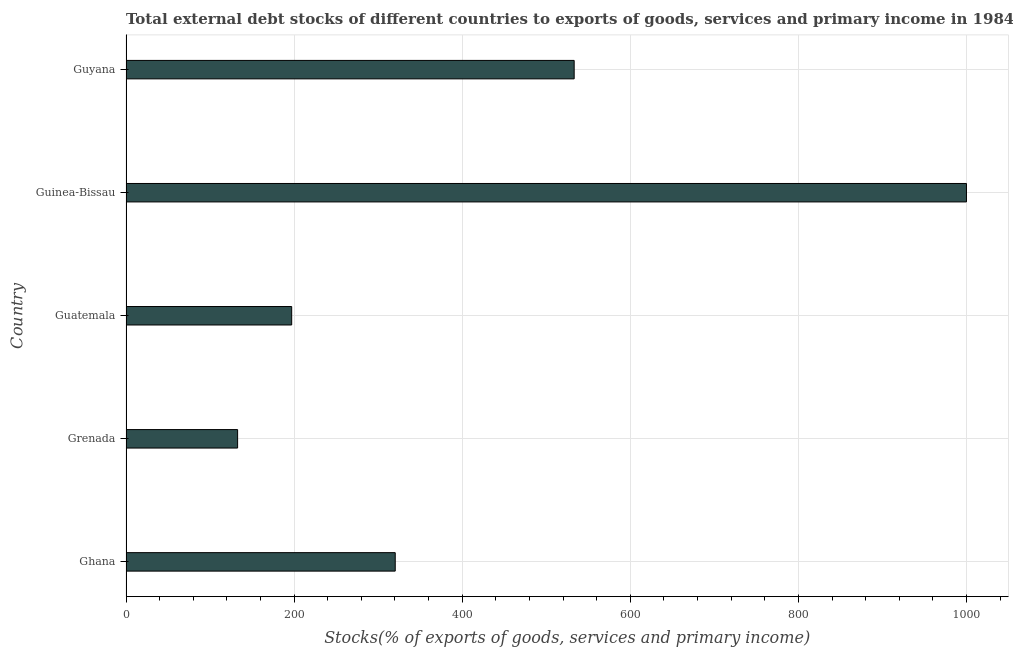Does the graph contain grids?
Give a very brief answer. Yes. What is the title of the graph?
Keep it short and to the point. Total external debt stocks of different countries to exports of goods, services and primary income in 1984. What is the label or title of the X-axis?
Your answer should be very brief. Stocks(% of exports of goods, services and primary income). What is the label or title of the Y-axis?
Offer a terse response. Country. Across all countries, what is the minimum external debt stocks?
Give a very brief answer. 132.79. In which country was the external debt stocks maximum?
Ensure brevity in your answer.  Guinea-Bissau. In which country was the external debt stocks minimum?
Offer a very short reply. Grenada. What is the sum of the external debt stocks?
Your answer should be very brief. 2183.47. What is the difference between the external debt stocks in Guatemala and Guinea-Bissau?
Your answer should be compact. -802.88. What is the average external debt stocks per country?
Provide a short and direct response. 436.69. What is the median external debt stocks?
Your response must be concise. 320.32. What is the ratio of the external debt stocks in Grenada to that in Guyana?
Your answer should be very brief. 0.25. Is the difference between the external debt stocks in Grenada and Guyana greater than the difference between any two countries?
Keep it short and to the point. No. What is the difference between the highest and the second highest external debt stocks?
Provide a short and direct response. 466.76. Is the sum of the external debt stocks in Ghana and Grenada greater than the maximum external debt stocks across all countries?
Offer a very short reply. No. What is the difference between the highest and the lowest external debt stocks?
Give a very brief answer. 867.21. In how many countries, is the external debt stocks greater than the average external debt stocks taken over all countries?
Your response must be concise. 2. How many bars are there?
Keep it short and to the point. 5. How many countries are there in the graph?
Keep it short and to the point. 5. What is the Stocks(% of exports of goods, services and primary income) in Ghana?
Your answer should be compact. 320.32. What is the Stocks(% of exports of goods, services and primary income) in Grenada?
Provide a short and direct response. 132.79. What is the Stocks(% of exports of goods, services and primary income) in Guatemala?
Your answer should be compact. 197.12. What is the Stocks(% of exports of goods, services and primary income) of Guyana?
Your answer should be very brief. 533.24. What is the difference between the Stocks(% of exports of goods, services and primary income) in Ghana and Grenada?
Keep it short and to the point. 187.53. What is the difference between the Stocks(% of exports of goods, services and primary income) in Ghana and Guatemala?
Provide a short and direct response. 123.21. What is the difference between the Stocks(% of exports of goods, services and primary income) in Ghana and Guinea-Bissau?
Your answer should be very brief. -679.68. What is the difference between the Stocks(% of exports of goods, services and primary income) in Ghana and Guyana?
Make the answer very short. -212.92. What is the difference between the Stocks(% of exports of goods, services and primary income) in Grenada and Guatemala?
Provide a succinct answer. -64.33. What is the difference between the Stocks(% of exports of goods, services and primary income) in Grenada and Guinea-Bissau?
Your response must be concise. -867.21. What is the difference between the Stocks(% of exports of goods, services and primary income) in Grenada and Guyana?
Provide a short and direct response. -400.45. What is the difference between the Stocks(% of exports of goods, services and primary income) in Guatemala and Guinea-Bissau?
Your response must be concise. -802.88. What is the difference between the Stocks(% of exports of goods, services and primary income) in Guatemala and Guyana?
Offer a very short reply. -336.12. What is the difference between the Stocks(% of exports of goods, services and primary income) in Guinea-Bissau and Guyana?
Provide a short and direct response. 466.76. What is the ratio of the Stocks(% of exports of goods, services and primary income) in Ghana to that in Grenada?
Your response must be concise. 2.41. What is the ratio of the Stocks(% of exports of goods, services and primary income) in Ghana to that in Guatemala?
Provide a succinct answer. 1.62. What is the ratio of the Stocks(% of exports of goods, services and primary income) in Ghana to that in Guinea-Bissau?
Ensure brevity in your answer.  0.32. What is the ratio of the Stocks(% of exports of goods, services and primary income) in Ghana to that in Guyana?
Offer a very short reply. 0.6. What is the ratio of the Stocks(% of exports of goods, services and primary income) in Grenada to that in Guatemala?
Your response must be concise. 0.67. What is the ratio of the Stocks(% of exports of goods, services and primary income) in Grenada to that in Guinea-Bissau?
Your answer should be compact. 0.13. What is the ratio of the Stocks(% of exports of goods, services and primary income) in Grenada to that in Guyana?
Give a very brief answer. 0.25. What is the ratio of the Stocks(% of exports of goods, services and primary income) in Guatemala to that in Guinea-Bissau?
Keep it short and to the point. 0.2. What is the ratio of the Stocks(% of exports of goods, services and primary income) in Guatemala to that in Guyana?
Offer a very short reply. 0.37. What is the ratio of the Stocks(% of exports of goods, services and primary income) in Guinea-Bissau to that in Guyana?
Your response must be concise. 1.88. 